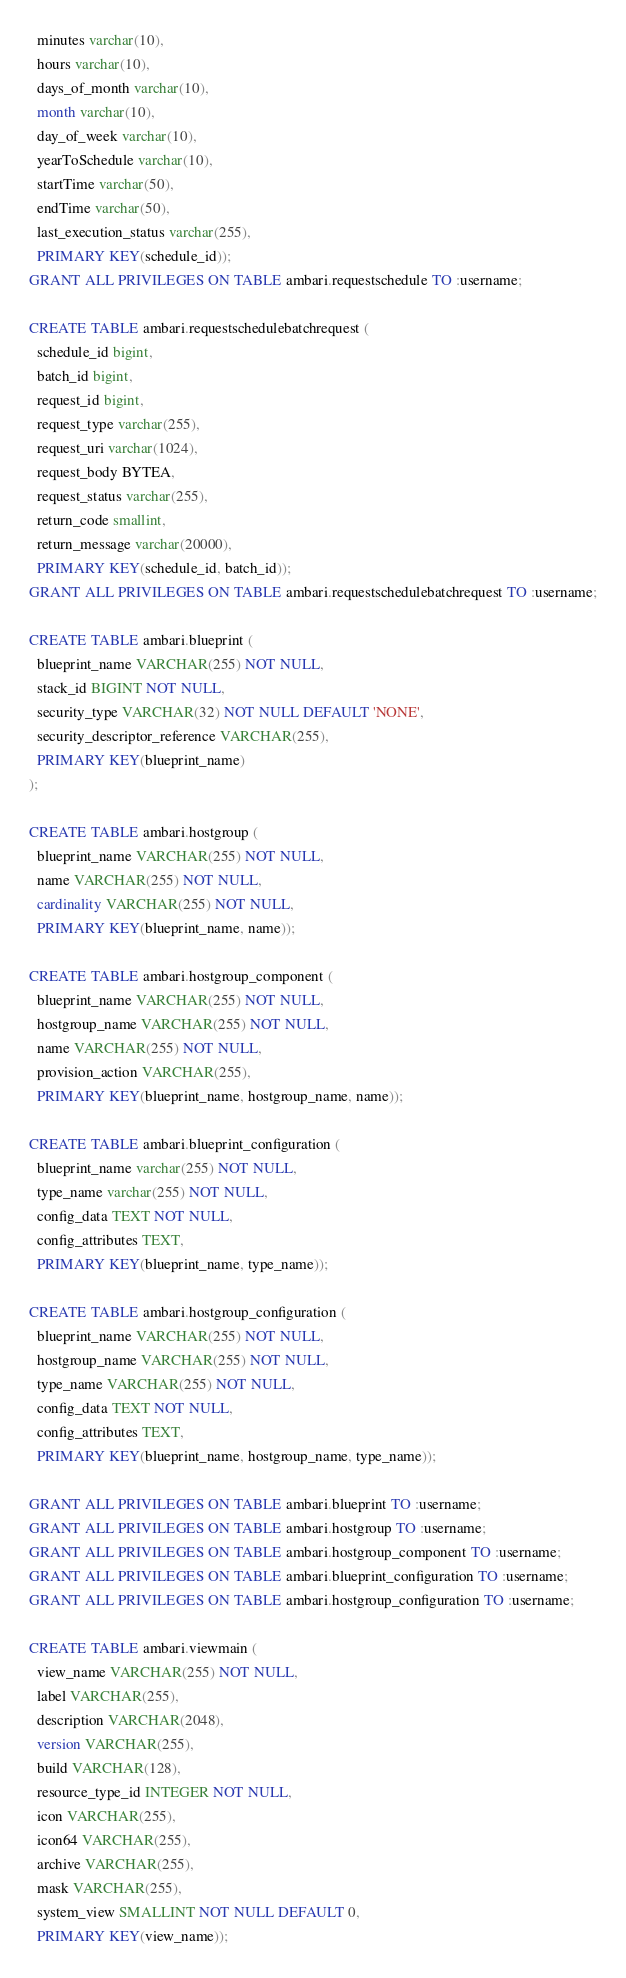<code> <loc_0><loc_0><loc_500><loc_500><_SQL_>  minutes varchar(10),
  hours varchar(10),
  days_of_month varchar(10),
  month varchar(10),
  day_of_week varchar(10),
  yearToSchedule varchar(10),
  startTime varchar(50),
  endTime varchar(50),
  last_execution_status varchar(255),
  PRIMARY KEY(schedule_id));
GRANT ALL PRIVILEGES ON TABLE ambari.requestschedule TO :username;

CREATE TABLE ambari.requestschedulebatchrequest (
  schedule_id bigint,
  batch_id bigint,
  request_id bigint,
  request_type varchar(255),
  request_uri varchar(1024),
  request_body BYTEA,
  request_status varchar(255),
  return_code smallint,
  return_message varchar(20000),
  PRIMARY KEY(schedule_id, batch_id));
GRANT ALL PRIVILEGES ON TABLE ambari.requestschedulebatchrequest TO :username;

CREATE TABLE ambari.blueprint (
  blueprint_name VARCHAR(255) NOT NULL,
  stack_id BIGINT NOT NULL,
  security_type VARCHAR(32) NOT NULL DEFAULT 'NONE',
  security_descriptor_reference VARCHAR(255),
  PRIMARY KEY(blueprint_name)
);

CREATE TABLE ambari.hostgroup (
  blueprint_name VARCHAR(255) NOT NULL,
  name VARCHAR(255) NOT NULL,
  cardinality VARCHAR(255) NOT NULL,
  PRIMARY KEY(blueprint_name, name));

CREATE TABLE ambari.hostgroup_component (
  blueprint_name VARCHAR(255) NOT NULL,
  hostgroup_name VARCHAR(255) NOT NULL,
  name VARCHAR(255) NOT NULL,
  provision_action VARCHAR(255),
  PRIMARY KEY(blueprint_name, hostgroup_name, name));

CREATE TABLE ambari.blueprint_configuration (
  blueprint_name varchar(255) NOT NULL,
  type_name varchar(255) NOT NULL,
  config_data TEXT NOT NULL,
  config_attributes TEXT,
  PRIMARY KEY(blueprint_name, type_name));

CREATE TABLE ambari.hostgroup_configuration (
  blueprint_name VARCHAR(255) NOT NULL,
  hostgroup_name VARCHAR(255) NOT NULL,
  type_name VARCHAR(255) NOT NULL,
  config_data TEXT NOT NULL,
  config_attributes TEXT,
  PRIMARY KEY(blueprint_name, hostgroup_name, type_name));

GRANT ALL PRIVILEGES ON TABLE ambari.blueprint TO :username;
GRANT ALL PRIVILEGES ON TABLE ambari.hostgroup TO :username;
GRANT ALL PRIVILEGES ON TABLE ambari.hostgroup_component TO :username;
GRANT ALL PRIVILEGES ON TABLE ambari.blueprint_configuration TO :username;
GRANT ALL PRIVILEGES ON TABLE ambari.hostgroup_configuration TO :username;

CREATE TABLE ambari.viewmain (
  view_name VARCHAR(255) NOT NULL,
  label VARCHAR(255),
  description VARCHAR(2048),
  version VARCHAR(255),
  build VARCHAR(128),
  resource_type_id INTEGER NOT NULL,
  icon VARCHAR(255),
  icon64 VARCHAR(255),
  archive VARCHAR(255),
  mask VARCHAR(255),
  system_view SMALLINT NOT NULL DEFAULT 0,
  PRIMARY KEY(view_name));
</code> 